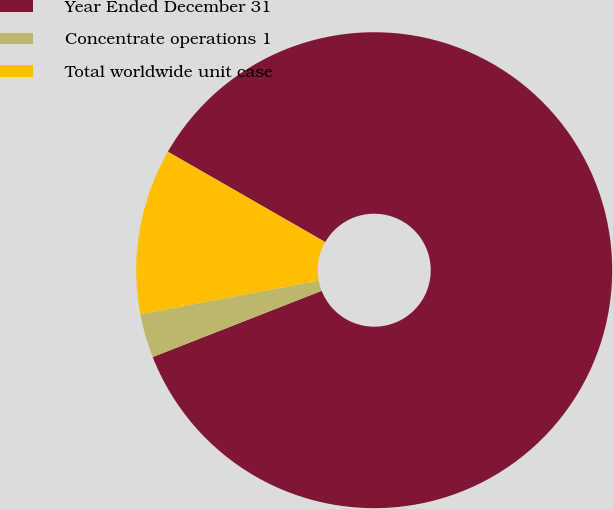Convert chart to OTSL. <chart><loc_0><loc_0><loc_500><loc_500><pie_chart><fcel>Year Ended December 31<fcel>Concentrate operations 1<fcel>Total worldwide unit case<nl><fcel>85.75%<fcel>2.98%<fcel>11.26%<nl></chart> 